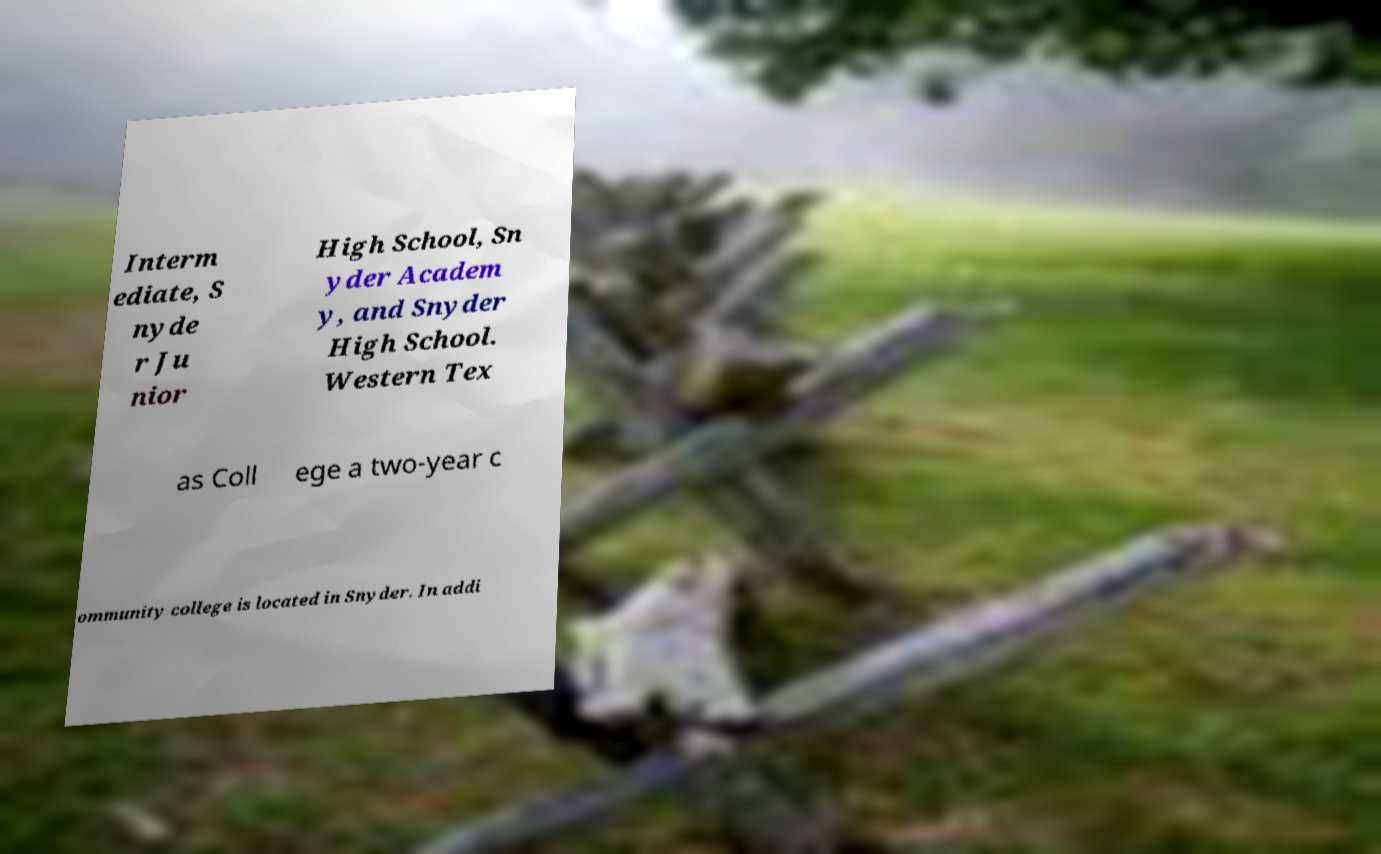What messages or text are displayed in this image? I need them in a readable, typed format. Interm ediate, S nyde r Ju nior High School, Sn yder Academ y, and Snyder High School. Western Tex as Coll ege a two-year c ommunity college is located in Snyder. In addi 